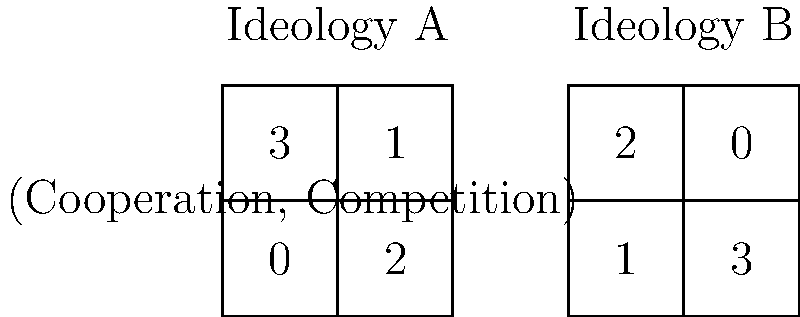Consider a simplified game theory model representing two political ideologies, A and B, with their payoff matrices shown above. The rows represent the choice to cooperate or compete, while the columns represent the same choices for the opposing ideology. Assuming both ideologies act rationally to maximize their own benefit, what is the Nash equilibrium of this game, and what does it reveal about the potential oversimplification of political ideologies in such models? To find the Nash equilibrium, we need to analyze each ideology's best responses to the other's strategies:

1. For Ideology A:
   - If B cooperates, A's best response is to cooperate (payoff 3 vs 0)
   - If B competes, A's best response is to compete (payoff 2 vs 1)

2. For Ideology B:
   - If A cooperates, B's best response is to cooperate (payoff 2 vs 1)
   - If A competes, B's best response is to compete (payoff 3 vs 0)

3. The Nash equilibrium occurs when both ideologies choose strategies that are best responses to each other. In this case, there are two pure strategy Nash equilibria:
   - (Cooperate, Cooperate) with payoffs (3, 2)
   - (Compete, Compete) with payoffs (2, 3)

4. This result reveals several oversimplifications:
   a) Binary choices: Real political ideologies have more nuanced options than just "cooperate" or "compete".
   b) Static payoffs: In reality, the benefits of cooperation or competition may change over time or in different contexts.
   c) Perfect rationality: The model assumes both ideologies always act to maximize their immediate benefit, ignoring factors like long-term consequences or ethical considerations.
   d) Symmetry: The model suggests that both ideologies have similar structures and motivations, which may not be true in complex political landscapes.
   e) Zero-sum thinking: The game implies that one ideology's gain is often the other's loss, which oversimplifies the potential for mutually beneficial outcomes in real political interactions.

5. The existence of two equilibria also highlights the potential for coordination problems and the importance of communication and trust in political interactions, which are not captured in this simplified model.
Answer: Two Nash equilibria: (Cooperate, Cooperate) and (Compete, Compete); reveals oversimplifications in binary choices, static payoffs, assumed rationality, ideological symmetry, and zero-sum thinking. 